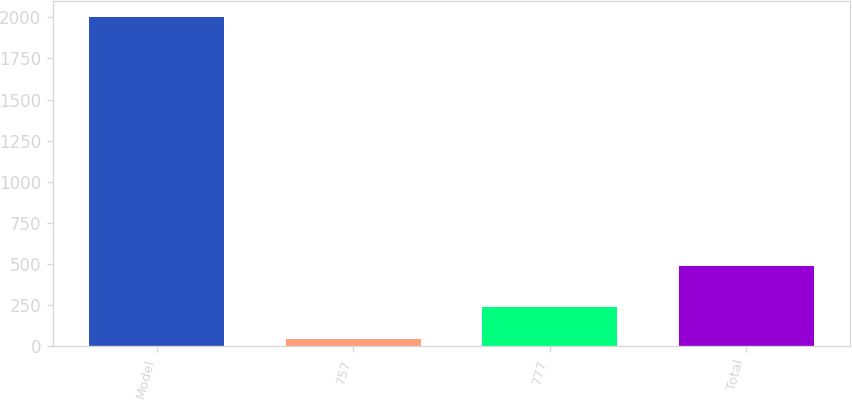<chart> <loc_0><loc_0><loc_500><loc_500><bar_chart><fcel>Model<fcel>757<fcel>777<fcel>Total<nl><fcel>2000<fcel>45<fcel>240.5<fcel>489<nl></chart> 